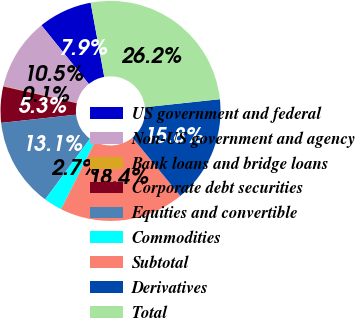Convert chart to OTSL. <chart><loc_0><loc_0><loc_500><loc_500><pie_chart><fcel>US government and federal<fcel>Non-US government and agency<fcel>Bank loans and bridge loans<fcel>Corporate debt securities<fcel>Equities and convertible<fcel>Commodities<fcel>Subtotal<fcel>Derivatives<fcel>Total<nl><fcel>7.92%<fcel>10.53%<fcel>0.09%<fcel>5.31%<fcel>13.14%<fcel>2.7%<fcel>18.36%<fcel>15.75%<fcel>26.19%<nl></chart> 